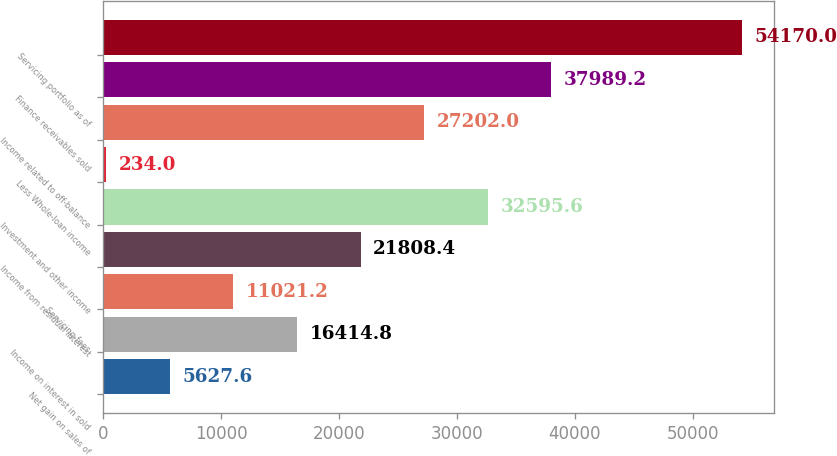Convert chart. <chart><loc_0><loc_0><loc_500><loc_500><bar_chart><fcel>Net gain on sales of<fcel>Income on interest in sold<fcel>Servicing fees<fcel>Income from residual interest<fcel>Investment and other income<fcel>Less Whole-loan income<fcel>Income related to off-balance<fcel>Finance receivables sold<fcel>Servicing portfolio as of<nl><fcel>5627.6<fcel>16414.8<fcel>11021.2<fcel>21808.4<fcel>32595.6<fcel>234<fcel>27202<fcel>37989.2<fcel>54170<nl></chart> 